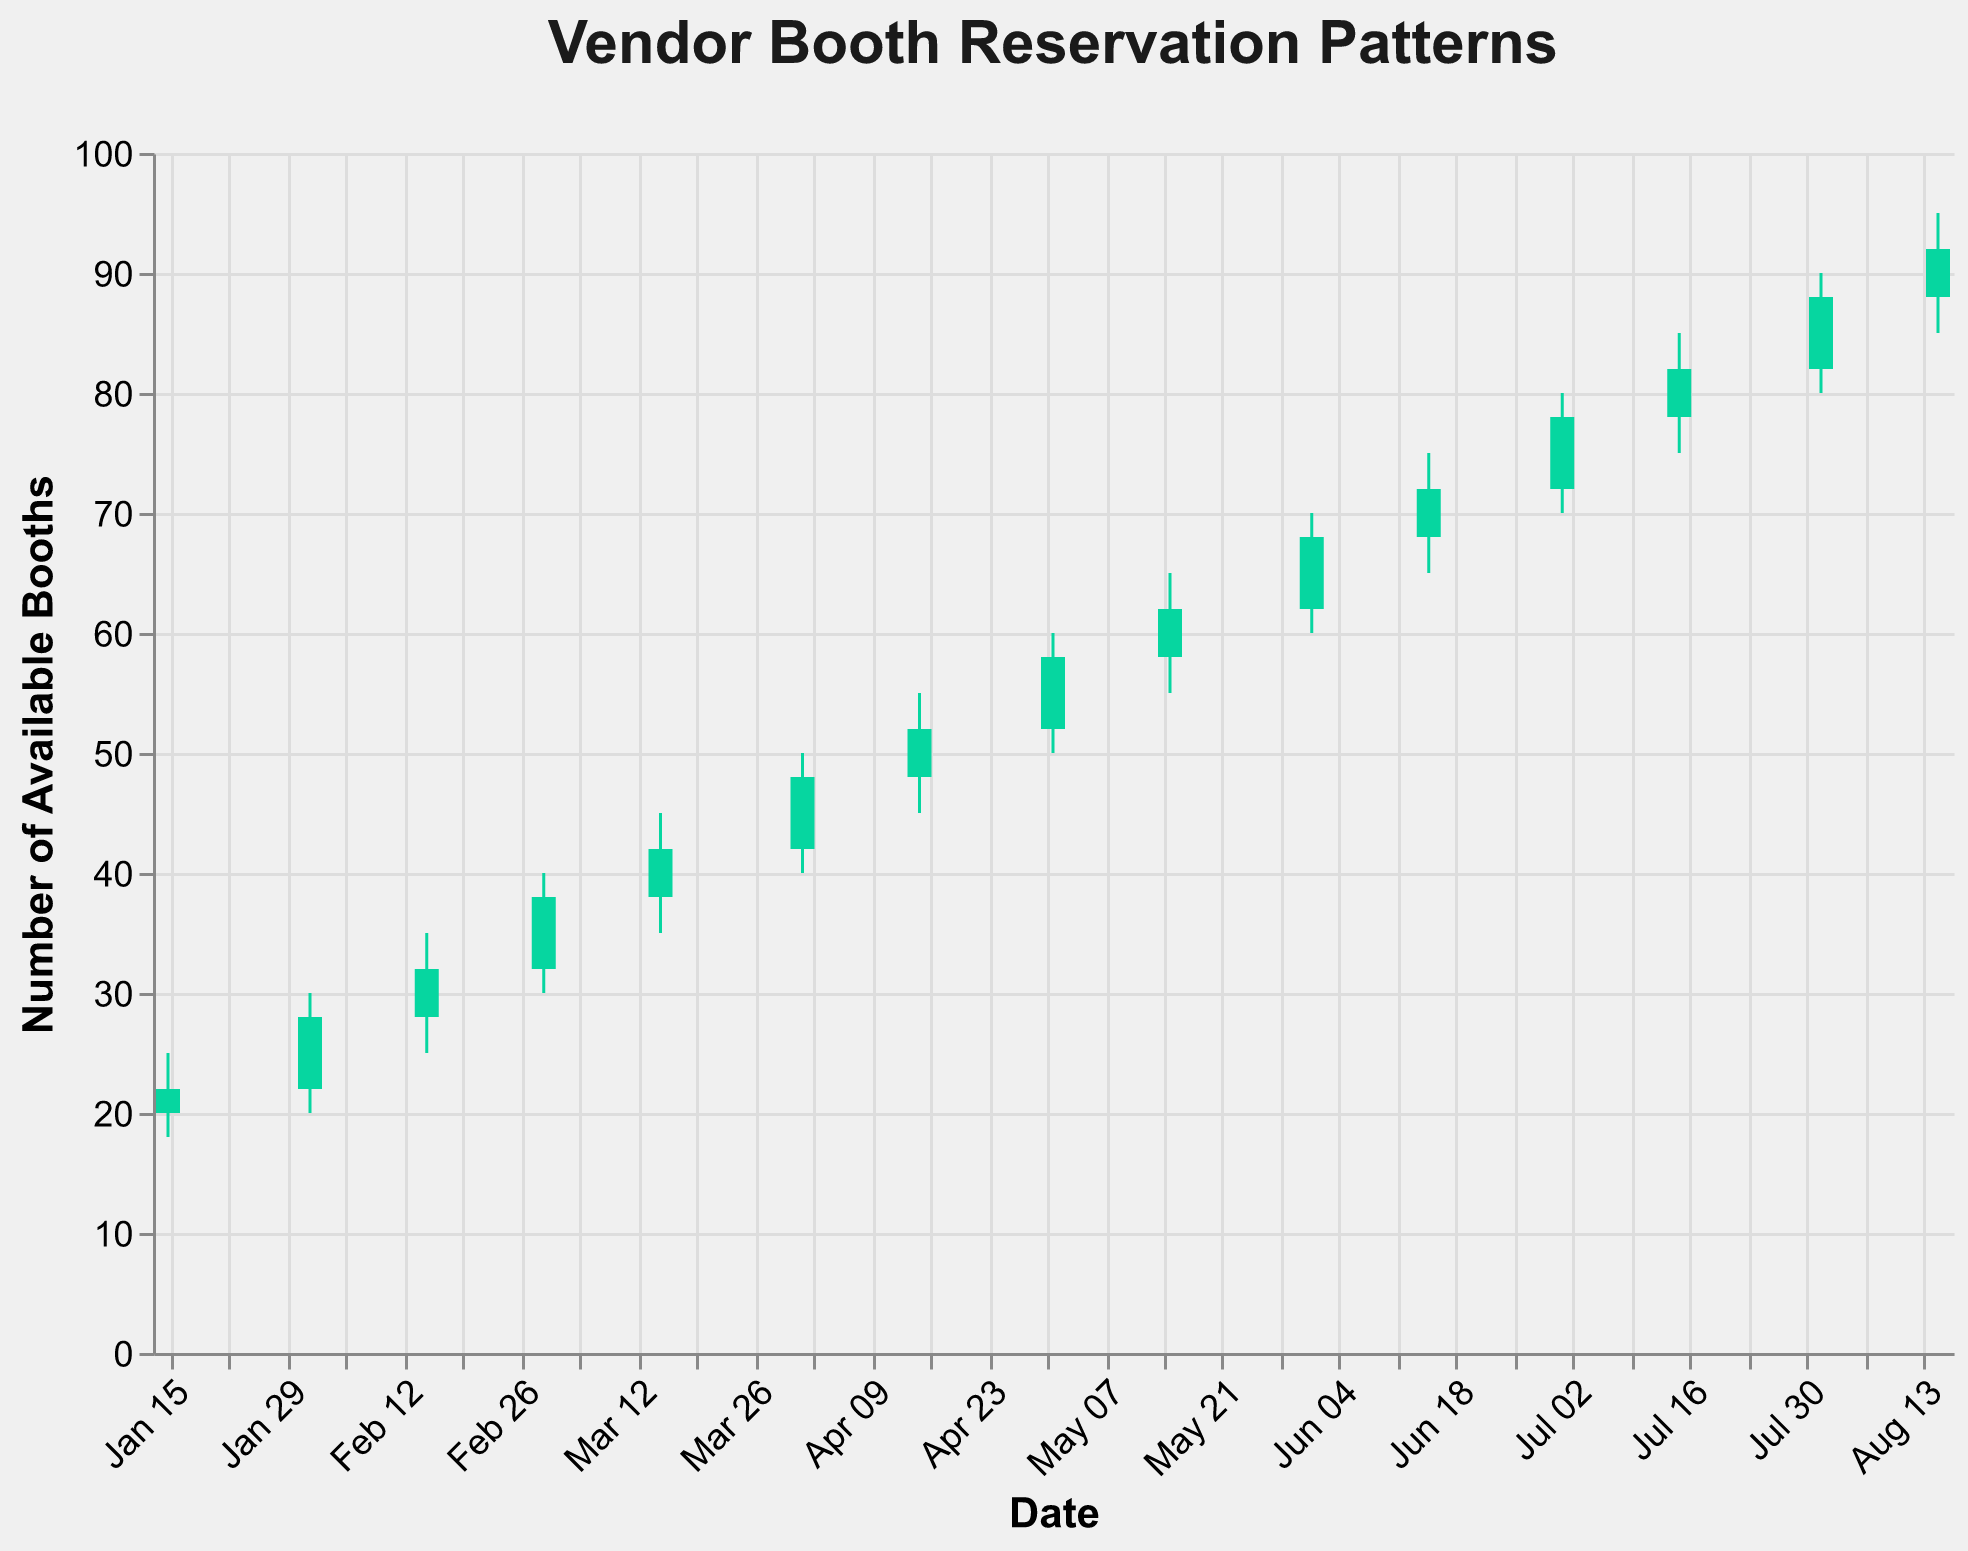What's the title of the figure? The title is displayed at the top center of the figure in bold and large font size, making it easily noticeable.
Answer: Vendor Booth Reservation Patterns What is the highest number of available booths on January 15, 2023? Look at the data point for January 15, 2023, and identify the High value.
Answer: 25 How many data points are shown in the figure? Count the number of different dates on the x-axis. There are 15 dates ranging from January 15, 2023, to August 15, 2023.
Answer: 15 What was the opening number of booths available on March 15, 2023? Observe the data point for the date March 15, 2023. The opening value is listed.
Answer: 38 Which date has the lowest number of booths available, and what is that number? Compare Low values of all data points to find the minimum value and its corresponding date. This value occurs on January 15, 2023.
Answer: January 15, 2023, 18 Between April 15, 2023, and June 1, 2023, which date experienced the highest number of booths available at its peak, and what was that number? Observe the High values for April 15, 2023; May 1, 2023; May 15, 2023; and June 1, 2023. The highest value is 70 on June 1, 2023.
Answer: June 1, 2023, 70 Comparing the data points of May 1, 2023, and June 15, 2023, which date had a higher closing number of booths available, and by how much? Check the Close values for the two dates and calculate the difference. May 1, 2023: 58, and June 15, 2023: 72. The difference is 72 - 58.
Answer: June 15, 2023, 14 What can you infer from the trend of booth availability over the planning period? Analyze the overall pattern by looking at the progression of Open, High, Low, and Close values from January to August. All values increase, indicating an upward trend in booth availability over time.
Answer: Increasing trend On February 1, 2023, was the closing number of booths available higher or lower than the opening number, and by how much? Compare the Open and Close values on February 1, 2023. Open is 22, and Close is 28. The difference is 28 - 22.
Answer: Higher by 6 